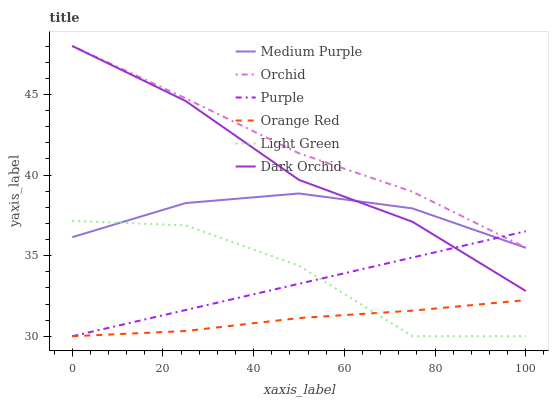Does Orange Red have the minimum area under the curve?
Answer yes or no. Yes. Does Orchid have the maximum area under the curve?
Answer yes or no. Yes. Does Dark Orchid have the minimum area under the curve?
Answer yes or no. No. Does Dark Orchid have the maximum area under the curve?
Answer yes or no. No. Is Purple the smoothest?
Answer yes or no. Yes. Is Light Green the roughest?
Answer yes or no. Yes. Is Dark Orchid the smoothest?
Answer yes or no. No. Is Dark Orchid the roughest?
Answer yes or no. No. Does Dark Orchid have the lowest value?
Answer yes or no. No. Does Orchid have the highest value?
Answer yes or no. Yes. Does Medium Purple have the highest value?
Answer yes or no. No. Is Orange Red less than Dark Orchid?
Answer yes or no. Yes. Is Orchid greater than Orange Red?
Answer yes or no. Yes. Does Light Green intersect Orange Red?
Answer yes or no. Yes. Is Light Green less than Orange Red?
Answer yes or no. No. Is Light Green greater than Orange Red?
Answer yes or no. No. Does Orange Red intersect Dark Orchid?
Answer yes or no. No. 